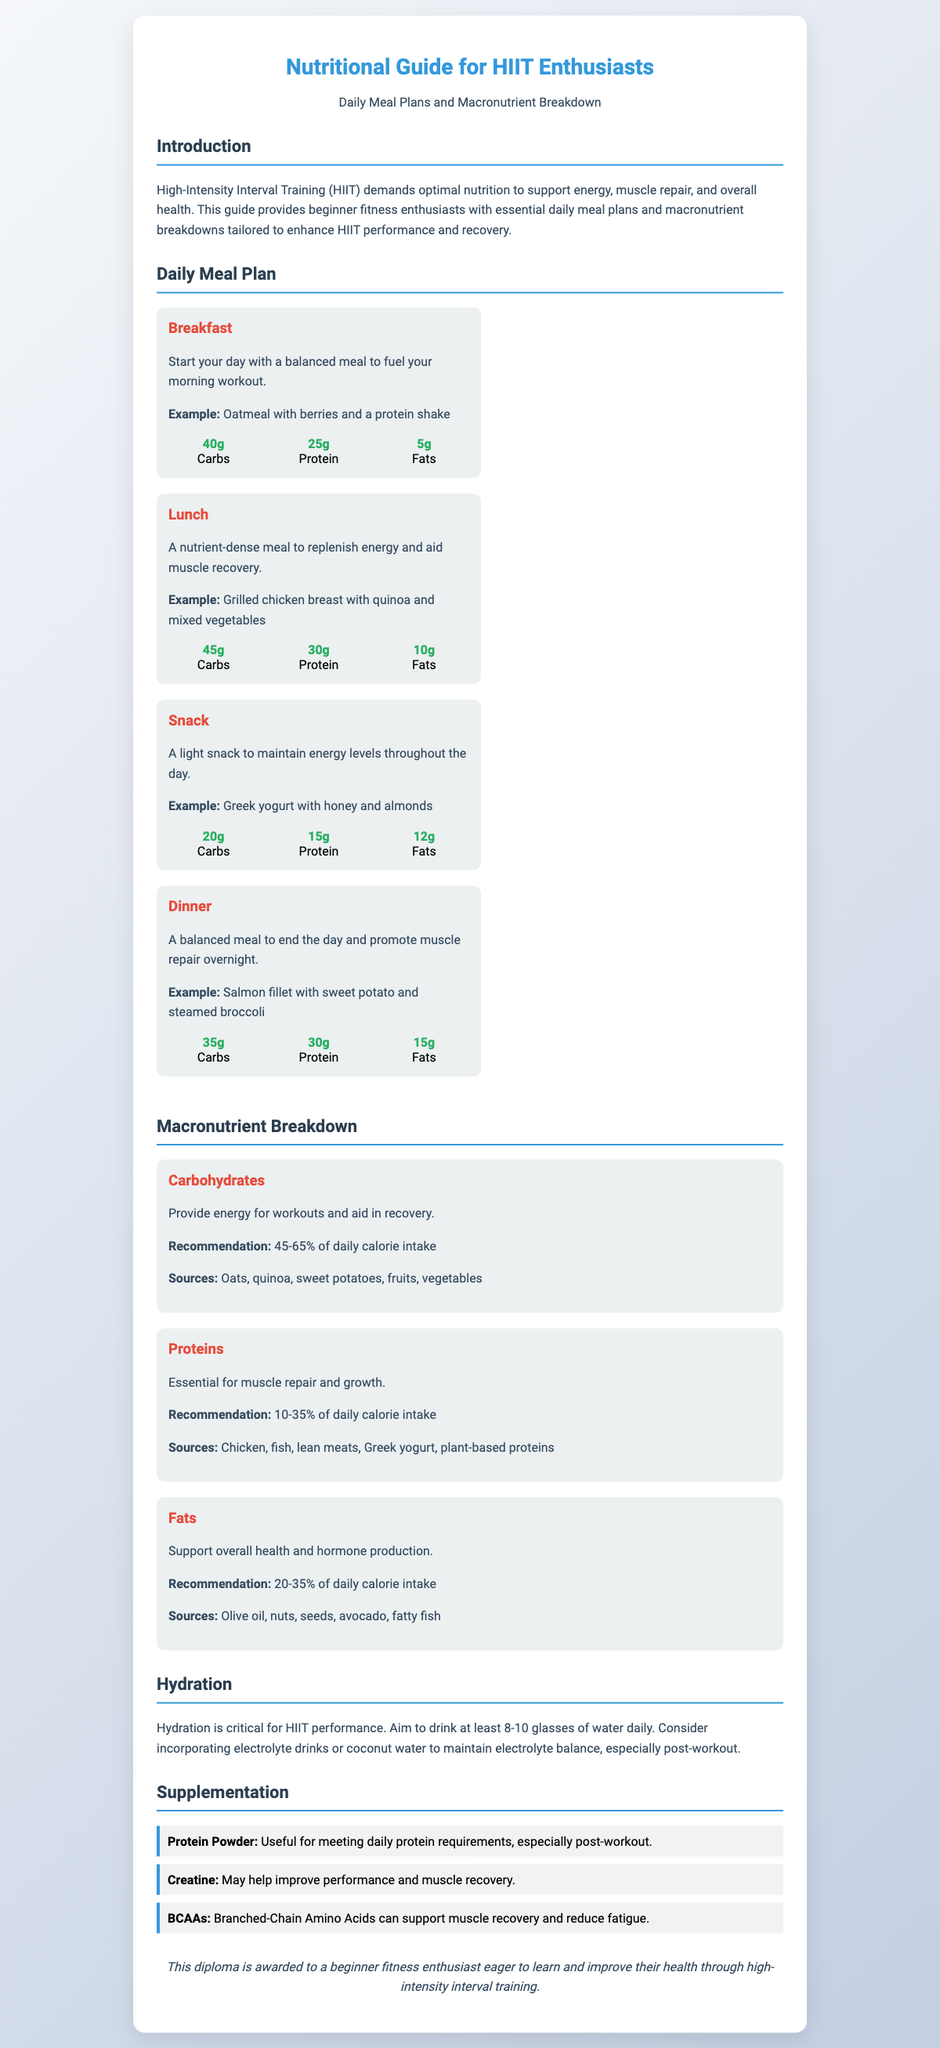what is the title of the diploma? The title of the diploma is indicated at the top of the document.
Answer: Nutritional Guide for HIIT Enthusiasts how many grams of protein are in the breakfast example? The amount of protein in the breakfast example is specified in the macronutrient breakdown under breakfast.
Answer: 25g what percentage of daily calorie intake is recommended for carbohydrates? The document provides recommendations for macronutrient distributions.
Answer: 45-65% what type of meal is included as an example for lunch? The type of meal for lunch is described in the meal section focused on lunch.
Answer: Grilled chicken breast with quinoa and mixed vegetables which supplement is mentioned for improving performance and muscle recovery? The document lists supplements with their benefits, and one is specifically related to performance.
Answer: Creatine how many glasses of water are recommended for daily hydration? The hydration section mentions the specific amount of water recommended for daily intake.
Answer: 8-10 glasses what is a recommended source of fats? The macronutrient breakdown section specifies various sources for fats.
Answer: Olive oil what is the purpose of protein powder according to the document? The document defines the use of protein powder in the supplementation section.
Answer: Meeting daily protein requirements 